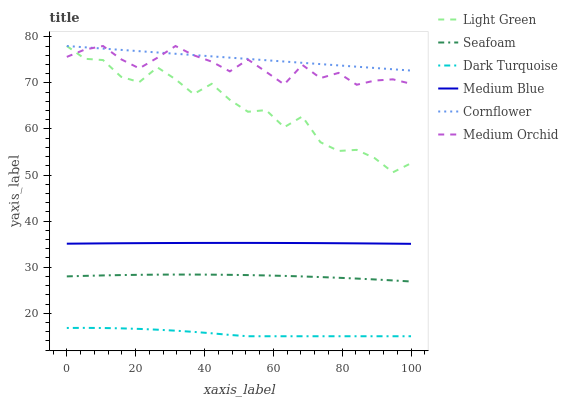Does Medium Orchid have the minimum area under the curve?
Answer yes or no. No. Does Medium Orchid have the maximum area under the curve?
Answer yes or no. No. Is Dark Turquoise the smoothest?
Answer yes or no. No. Is Dark Turquoise the roughest?
Answer yes or no. No. Does Medium Orchid have the lowest value?
Answer yes or no. No. Does Dark Turquoise have the highest value?
Answer yes or no. No. Is Dark Turquoise less than Cornflower?
Answer yes or no. Yes. Is Medium Orchid greater than Dark Turquoise?
Answer yes or no. Yes. Does Dark Turquoise intersect Cornflower?
Answer yes or no. No. 